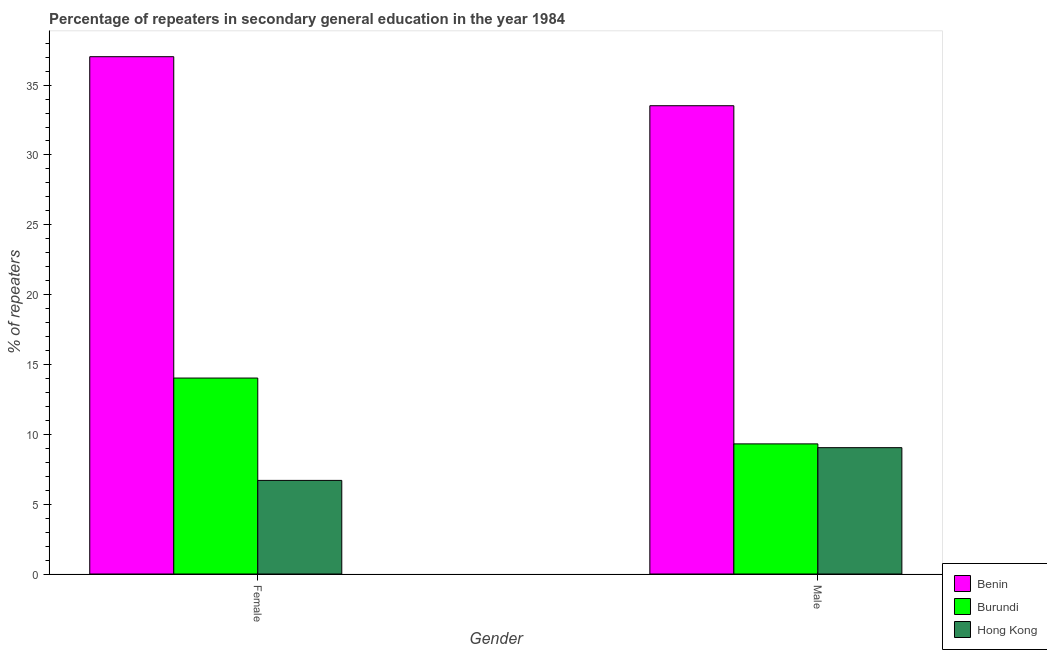How many bars are there on the 1st tick from the right?
Offer a terse response. 3. What is the percentage of female repeaters in Benin?
Provide a short and direct response. 37.03. Across all countries, what is the maximum percentage of female repeaters?
Give a very brief answer. 37.03. Across all countries, what is the minimum percentage of female repeaters?
Your answer should be compact. 6.7. In which country was the percentage of female repeaters maximum?
Offer a very short reply. Benin. In which country was the percentage of male repeaters minimum?
Offer a very short reply. Hong Kong. What is the total percentage of female repeaters in the graph?
Your answer should be compact. 57.76. What is the difference between the percentage of male repeaters in Benin and that in Hong Kong?
Provide a short and direct response. 24.48. What is the difference between the percentage of male repeaters in Hong Kong and the percentage of female repeaters in Burundi?
Your response must be concise. -4.98. What is the average percentage of male repeaters per country?
Offer a very short reply. 17.29. What is the difference between the percentage of female repeaters and percentage of male repeaters in Hong Kong?
Your answer should be compact. -2.34. In how many countries, is the percentage of female repeaters greater than 20 %?
Your response must be concise. 1. What is the ratio of the percentage of female repeaters in Burundi to that in Benin?
Give a very brief answer. 0.38. In how many countries, is the percentage of male repeaters greater than the average percentage of male repeaters taken over all countries?
Make the answer very short. 1. What does the 2nd bar from the left in Female represents?
Make the answer very short. Burundi. What does the 3rd bar from the right in Female represents?
Provide a short and direct response. Benin. How many bars are there?
Keep it short and to the point. 6. How many countries are there in the graph?
Ensure brevity in your answer.  3. How many legend labels are there?
Provide a short and direct response. 3. What is the title of the graph?
Provide a short and direct response. Percentage of repeaters in secondary general education in the year 1984. Does "Austria" appear as one of the legend labels in the graph?
Your answer should be very brief. No. What is the label or title of the Y-axis?
Ensure brevity in your answer.  % of repeaters. What is the % of repeaters of Benin in Female?
Provide a succinct answer. 37.03. What is the % of repeaters in Burundi in Female?
Ensure brevity in your answer.  14.03. What is the % of repeaters in Hong Kong in Female?
Offer a terse response. 6.7. What is the % of repeaters in Benin in Male?
Your answer should be very brief. 33.52. What is the % of repeaters of Burundi in Male?
Keep it short and to the point. 9.31. What is the % of repeaters in Hong Kong in Male?
Offer a very short reply. 9.04. Across all Gender, what is the maximum % of repeaters in Benin?
Ensure brevity in your answer.  37.03. Across all Gender, what is the maximum % of repeaters of Burundi?
Your response must be concise. 14.03. Across all Gender, what is the maximum % of repeaters in Hong Kong?
Ensure brevity in your answer.  9.04. Across all Gender, what is the minimum % of repeaters in Benin?
Ensure brevity in your answer.  33.52. Across all Gender, what is the minimum % of repeaters in Burundi?
Provide a short and direct response. 9.31. Across all Gender, what is the minimum % of repeaters of Hong Kong?
Ensure brevity in your answer.  6.7. What is the total % of repeaters in Benin in the graph?
Provide a short and direct response. 70.56. What is the total % of repeaters in Burundi in the graph?
Make the answer very short. 23.34. What is the total % of repeaters of Hong Kong in the graph?
Keep it short and to the point. 15.75. What is the difference between the % of repeaters in Benin in Female and that in Male?
Your response must be concise. 3.51. What is the difference between the % of repeaters in Burundi in Female and that in Male?
Make the answer very short. 4.71. What is the difference between the % of repeaters of Hong Kong in Female and that in Male?
Provide a succinct answer. -2.34. What is the difference between the % of repeaters of Benin in Female and the % of repeaters of Burundi in Male?
Keep it short and to the point. 27.72. What is the difference between the % of repeaters in Benin in Female and the % of repeaters in Hong Kong in Male?
Make the answer very short. 27.99. What is the difference between the % of repeaters of Burundi in Female and the % of repeaters of Hong Kong in Male?
Give a very brief answer. 4.98. What is the average % of repeaters in Benin per Gender?
Give a very brief answer. 35.28. What is the average % of repeaters of Burundi per Gender?
Keep it short and to the point. 11.67. What is the average % of repeaters of Hong Kong per Gender?
Your answer should be very brief. 7.87. What is the difference between the % of repeaters of Benin and % of repeaters of Burundi in Female?
Your answer should be compact. 23.01. What is the difference between the % of repeaters of Benin and % of repeaters of Hong Kong in Female?
Provide a short and direct response. 30.33. What is the difference between the % of repeaters in Burundi and % of repeaters in Hong Kong in Female?
Offer a very short reply. 7.33. What is the difference between the % of repeaters in Benin and % of repeaters in Burundi in Male?
Offer a very short reply. 24.21. What is the difference between the % of repeaters in Benin and % of repeaters in Hong Kong in Male?
Ensure brevity in your answer.  24.48. What is the difference between the % of repeaters of Burundi and % of repeaters of Hong Kong in Male?
Your answer should be compact. 0.27. What is the ratio of the % of repeaters of Benin in Female to that in Male?
Your answer should be very brief. 1.1. What is the ratio of the % of repeaters of Burundi in Female to that in Male?
Your answer should be very brief. 1.51. What is the ratio of the % of repeaters of Hong Kong in Female to that in Male?
Make the answer very short. 0.74. What is the difference between the highest and the second highest % of repeaters of Benin?
Give a very brief answer. 3.51. What is the difference between the highest and the second highest % of repeaters in Burundi?
Offer a very short reply. 4.71. What is the difference between the highest and the second highest % of repeaters of Hong Kong?
Offer a terse response. 2.34. What is the difference between the highest and the lowest % of repeaters of Benin?
Provide a succinct answer. 3.51. What is the difference between the highest and the lowest % of repeaters of Burundi?
Offer a very short reply. 4.71. What is the difference between the highest and the lowest % of repeaters in Hong Kong?
Provide a succinct answer. 2.34. 